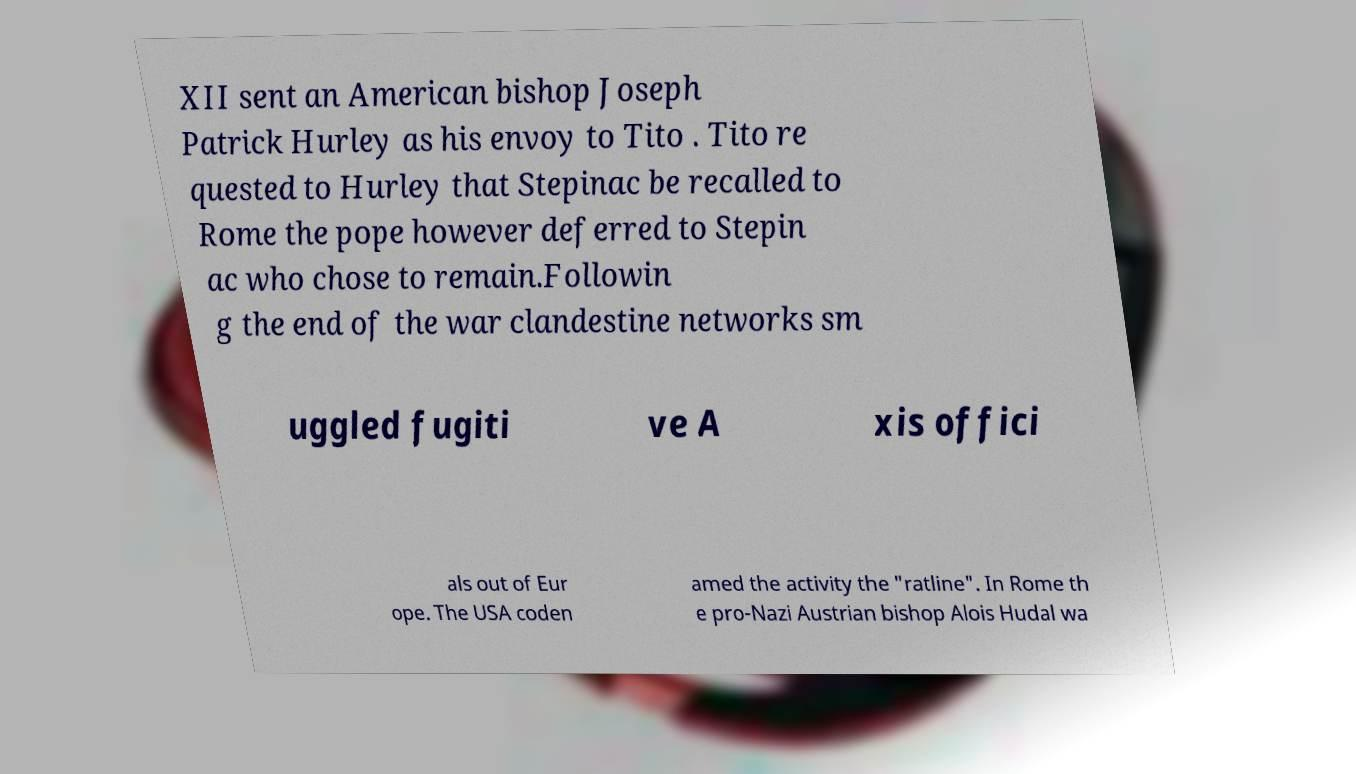Could you extract and type out the text from this image? XII sent an American bishop Joseph Patrick Hurley as his envoy to Tito . Tito re quested to Hurley that Stepinac be recalled to Rome the pope however deferred to Stepin ac who chose to remain.Followin g the end of the war clandestine networks sm uggled fugiti ve A xis offici als out of Eur ope. The USA coden amed the activity the "ratline". In Rome th e pro-Nazi Austrian bishop Alois Hudal wa 